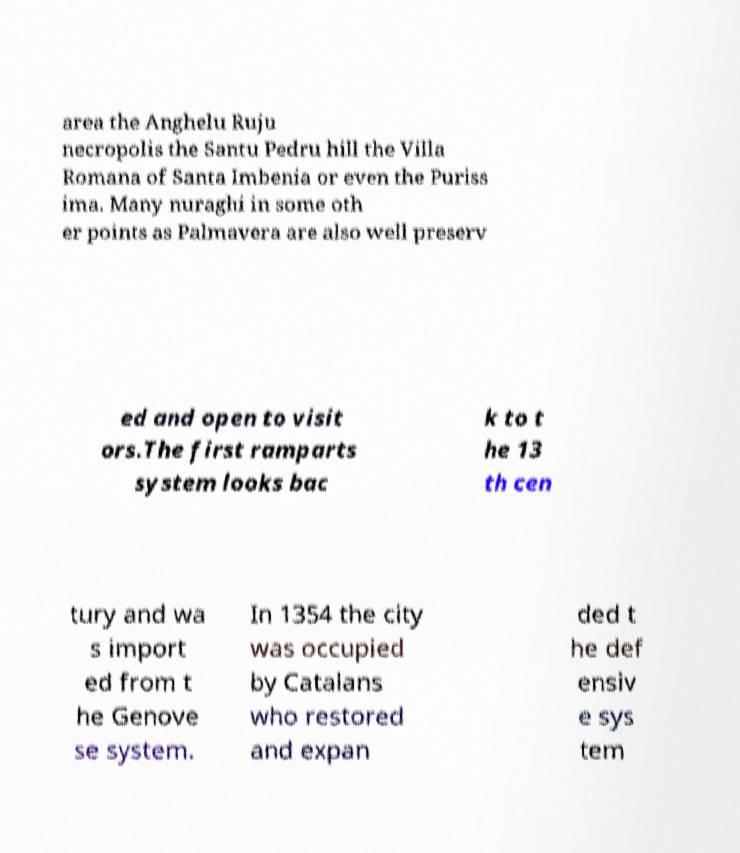For documentation purposes, I need the text within this image transcribed. Could you provide that? area the Anghelu Ruju necropolis the Santu Pedru hill the Villa Romana of Santa Imbenia or even the Puriss ima. Many nuraghi in some oth er points as Palmavera are also well preserv ed and open to visit ors.The first ramparts system looks bac k to t he 13 th cen tury and wa s import ed from t he Genove se system. In 1354 the city was occupied by Catalans who restored and expan ded t he def ensiv e sys tem 